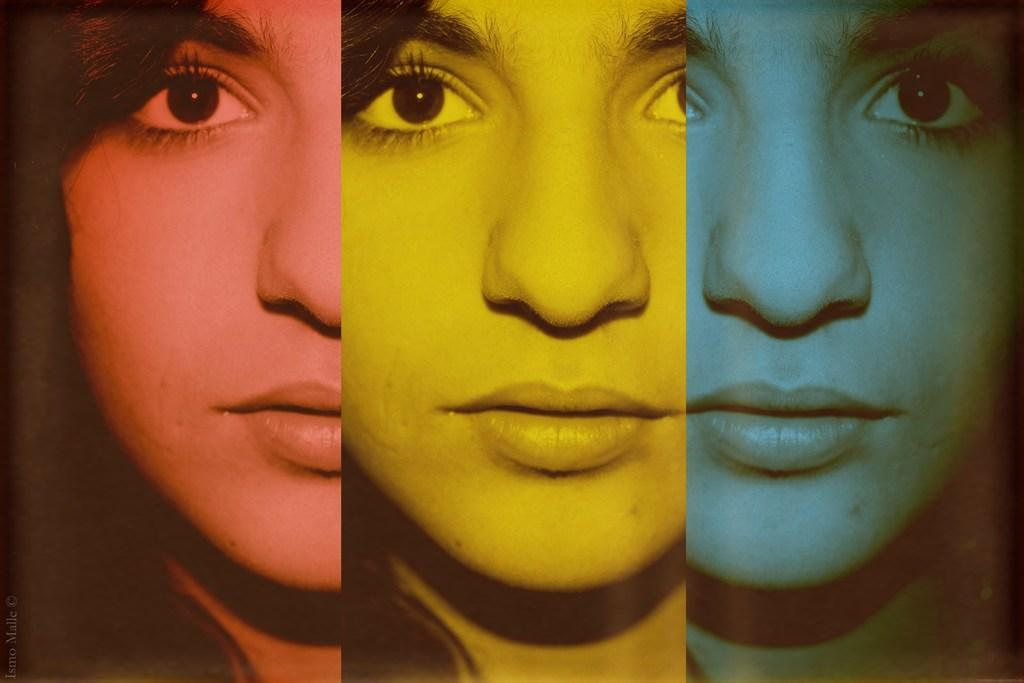What can be said about the nature of the image? The image is edited. What facial features can be seen in the image? Eyes, eyebrows, noses, and mouths are visible in the image. What type of desk is present in the image? There is no desk present in the image; it only features facial features. How is the pail being used in the image? There is no pail present in the image. 